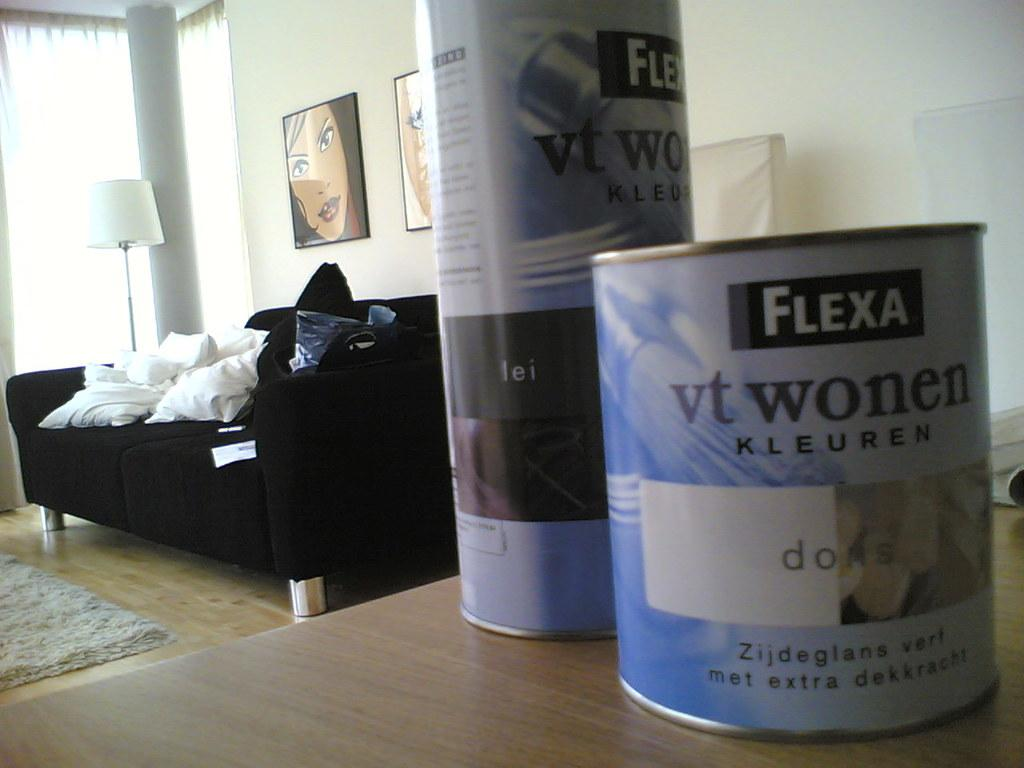<image>
Offer a succinct explanation of the picture presented. Cans of Flexa sit on a table in a living room. 